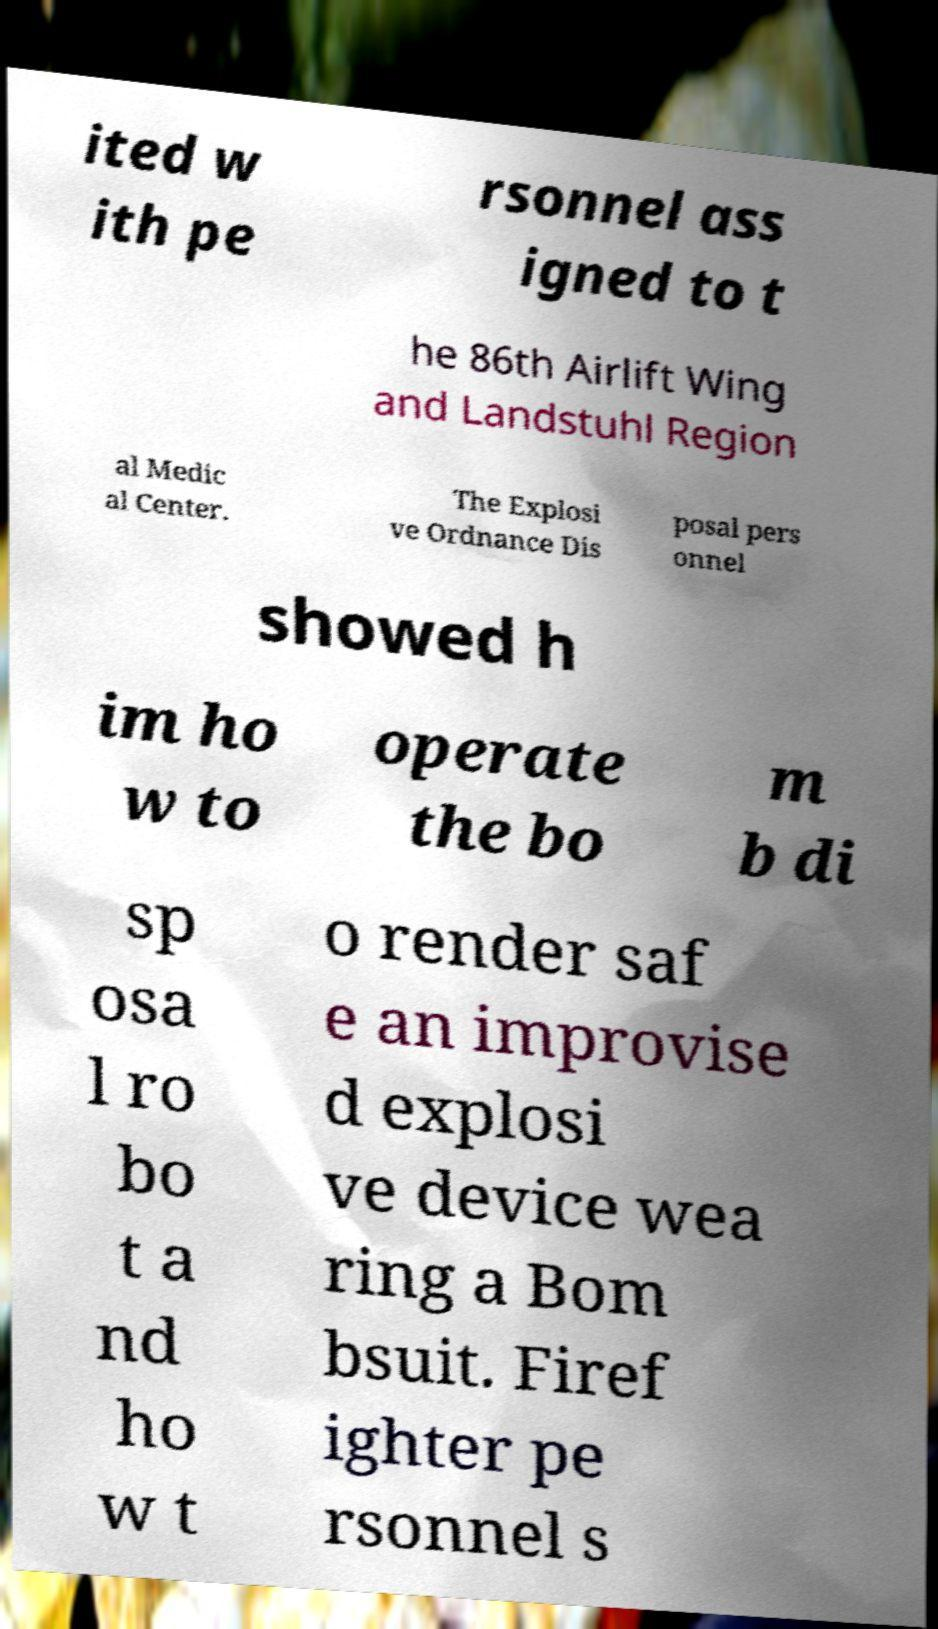Can you read and provide the text displayed in the image?This photo seems to have some interesting text. Can you extract and type it out for me? ited w ith pe rsonnel ass igned to t he 86th Airlift Wing and Landstuhl Region al Medic al Center. The Explosi ve Ordnance Dis posal pers onnel showed h im ho w to operate the bo m b di sp osa l ro bo t a nd ho w t o render saf e an improvise d explosi ve device wea ring a Bom bsuit. Firef ighter pe rsonnel s 